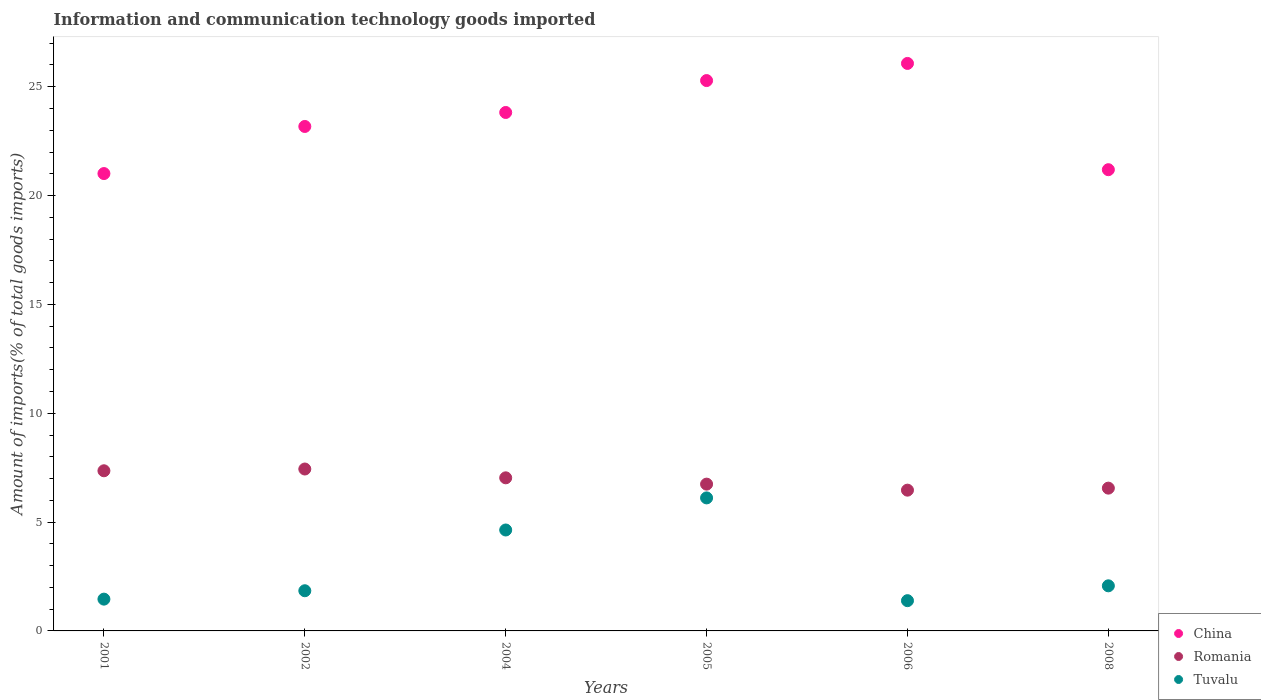Is the number of dotlines equal to the number of legend labels?
Give a very brief answer. Yes. What is the amount of goods imported in Romania in 2004?
Make the answer very short. 7.03. Across all years, what is the maximum amount of goods imported in Romania?
Give a very brief answer. 7.44. Across all years, what is the minimum amount of goods imported in China?
Your answer should be very brief. 21.01. What is the total amount of goods imported in Romania in the graph?
Make the answer very short. 41.6. What is the difference between the amount of goods imported in China in 2004 and that in 2006?
Keep it short and to the point. -2.25. What is the difference between the amount of goods imported in Romania in 2002 and the amount of goods imported in Tuvalu in 2001?
Give a very brief answer. 5.98. What is the average amount of goods imported in Tuvalu per year?
Your answer should be compact. 2.92. In the year 2008, what is the difference between the amount of goods imported in Tuvalu and amount of goods imported in China?
Make the answer very short. -19.12. In how many years, is the amount of goods imported in Tuvalu greater than 1 %?
Ensure brevity in your answer.  6. What is the ratio of the amount of goods imported in China in 2002 to that in 2004?
Offer a terse response. 0.97. Is the amount of goods imported in China in 2002 less than that in 2008?
Your answer should be compact. No. What is the difference between the highest and the second highest amount of goods imported in Romania?
Offer a terse response. 0.08. What is the difference between the highest and the lowest amount of goods imported in Tuvalu?
Provide a short and direct response. 4.72. Is it the case that in every year, the sum of the amount of goods imported in China and amount of goods imported in Tuvalu  is greater than the amount of goods imported in Romania?
Give a very brief answer. Yes. Is the amount of goods imported in Tuvalu strictly greater than the amount of goods imported in China over the years?
Give a very brief answer. No. How many dotlines are there?
Your response must be concise. 3. How many years are there in the graph?
Keep it short and to the point. 6. What is the difference between two consecutive major ticks on the Y-axis?
Ensure brevity in your answer.  5. Does the graph contain any zero values?
Your response must be concise. No. Where does the legend appear in the graph?
Offer a very short reply. Bottom right. What is the title of the graph?
Make the answer very short. Information and communication technology goods imported. Does "Russian Federation" appear as one of the legend labels in the graph?
Provide a succinct answer. No. What is the label or title of the X-axis?
Ensure brevity in your answer.  Years. What is the label or title of the Y-axis?
Ensure brevity in your answer.  Amount of imports(% of total goods imports). What is the Amount of imports(% of total goods imports) of China in 2001?
Your response must be concise. 21.01. What is the Amount of imports(% of total goods imports) of Romania in 2001?
Provide a succinct answer. 7.36. What is the Amount of imports(% of total goods imports) of Tuvalu in 2001?
Provide a short and direct response. 1.46. What is the Amount of imports(% of total goods imports) of China in 2002?
Your answer should be very brief. 23.17. What is the Amount of imports(% of total goods imports) in Romania in 2002?
Give a very brief answer. 7.44. What is the Amount of imports(% of total goods imports) of Tuvalu in 2002?
Make the answer very short. 1.85. What is the Amount of imports(% of total goods imports) in China in 2004?
Provide a succinct answer. 23.82. What is the Amount of imports(% of total goods imports) in Romania in 2004?
Your answer should be compact. 7.03. What is the Amount of imports(% of total goods imports) in Tuvalu in 2004?
Provide a succinct answer. 4.64. What is the Amount of imports(% of total goods imports) in China in 2005?
Keep it short and to the point. 25.28. What is the Amount of imports(% of total goods imports) in Romania in 2005?
Make the answer very short. 6.74. What is the Amount of imports(% of total goods imports) in Tuvalu in 2005?
Provide a succinct answer. 6.11. What is the Amount of imports(% of total goods imports) in China in 2006?
Offer a terse response. 26.07. What is the Amount of imports(% of total goods imports) in Romania in 2006?
Your answer should be very brief. 6.47. What is the Amount of imports(% of total goods imports) in Tuvalu in 2006?
Make the answer very short. 1.39. What is the Amount of imports(% of total goods imports) of China in 2008?
Give a very brief answer. 21.19. What is the Amount of imports(% of total goods imports) of Romania in 2008?
Give a very brief answer. 6.56. What is the Amount of imports(% of total goods imports) of Tuvalu in 2008?
Provide a succinct answer. 2.07. Across all years, what is the maximum Amount of imports(% of total goods imports) in China?
Your answer should be compact. 26.07. Across all years, what is the maximum Amount of imports(% of total goods imports) in Romania?
Ensure brevity in your answer.  7.44. Across all years, what is the maximum Amount of imports(% of total goods imports) in Tuvalu?
Keep it short and to the point. 6.11. Across all years, what is the minimum Amount of imports(% of total goods imports) in China?
Make the answer very short. 21.01. Across all years, what is the minimum Amount of imports(% of total goods imports) in Romania?
Your answer should be compact. 6.47. Across all years, what is the minimum Amount of imports(% of total goods imports) in Tuvalu?
Give a very brief answer. 1.39. What is the total Amount of imports(% of total goods imports) of China in the graph?
Your answer should be very brief. 140.54. What is the total Amount of imports(% of total goods imports) in Romania in the graph?
Your answer should be very brief. 41.6. What is the total Amount of imports(% of total goods imports) of Tuvalu in the graph?
Keep it short and to the point. 17.51. What is the difference between the Amount of imports(% of total goods imports) in China in 2001 and that in 2002?
Offer a very short reply. -2.16. What is the difference between the Amount of imports(% of total goods imports) in Romania in 2001 and that in 2002?
Ensure brevity in your answer.  -0.08. What is the difference between the Amount of imports(% of total goods imports) in Tuvalu in 2001 and that in 2002?
Make the answer very short. -0.39. What is the difference between the Amount of imports(% of total goods imports) of China in 2001 and that in 2004?
Offer a very short reply. -2.81. What is the difference between the Amount of imports(% of total goods imports) of Romania in 2001 and that in 2004?
Offer a terse response. 0.32. What is the difference between the Amount of imports(% of total goods imports) in Tuvalu in 2001 and that in 2004?
Ensure brevity in your answer.  -3.18. What is the difference between the Amount of imports(% of total goods imports) of China in 2001 and that in 2005?
Offer a terse response. -4.27. What is the difference between the Amount of imports(% of total goods imports) in Romania in 2001 and that in 2005?
Keep it short and to the point. 0.61. What is the difference between the Amount of imports(% of total goods imports) of Tuvalu in 2001 and that in 2005?
Give a very brief answer. -4.65. What is the difference between the Amount of imports(% of total goods imports) of China in 2001 and that in 2006?
Your response must be concise. -5.06. What is the difference between the Amount of imports(% of total goods imports) of Romania in 2001 and that in 2006?
Provide a succinct answer. 0.89. What is the difference between the Amount of imports(% of total goods imports) in Tuvalu in 2001 and that in 2006?
Your answer should be very brief. 0.07. What is the difference between the Amount of imports(% of total goods imports) in China in 2001 and that in 2008?
Offer a terse response. -0.18. What is the difference between the Amount of imports(% of total goods imports) of Romania in 2001 and that in 2008?
Provide a short and direct response. 0.8. What is the difference between the Amount of imports(% of total goods imports) of Tuvalu in 2001 and that in 2008?
Provide a succinct answer. -0.61. What is the difference between the Amount of imports(% of total goods imports) of China in 2002 and that in 2004?
Your response must be concise. -0.64. What is the difference between the Amount of imports(% of total goods imports) of Romania in 2002 and that in 2004?
Ensure brevity in your answer.  0.4. What is the difference between the Amount of imports(% of total goods imports) of Tuvalu in 2002 and that in 2004?
Provide a short and direct response. -2.79. What is the difference between the Amount of imports(% of total goods imports) in China in 2002 and that in 2005?
Give a very brief answer. -2.11. What is the difference between the Amount of imports(% of total goods imports) of Romania in 2002 and that in 2005?
Offer a very short reply. 0.69. What is the difference between the Amount of imports(% of total goods imports) of Tuvalu in 2002 and that in 2005?
Your answer should be compact. -4.26. What is the difference between the Amount of imports(% of total goods imports) of China in 2002 and that in 2006?
Ensure brevity in your answer.  -2.9. What is the difference between the Amount of imports(% of total goods imports) in Romania in 2002 and that in 2006?
Offer a terse response. 0.97. What is the difference between the Amount of imports(% of total goods imports) in Tuvalu in 2002 and that in 2006?
Ensure brevity in your answer.  0.46. What is the difference between the Amount of imports(% of total goods imports) in China in 2002 and that in 2008?
Offer a very short reply. 1.99. What is the difference between the Amount of imports(% of total goods imports) in Romania in 2002 and that in 2008?
Your response must be concise. 0.88. What is the difference between the Amount of imports(% of total goods imports) of Tuvalu in 2002 and that in 2008?
Ensure brevity in your answer.  -0.23. What is the difference between the Amount of imports(% of total goods imports) in China in 2004 and that in 2005?
Your answer should be compact. -1.47. What is the difference between the Amount of imports(% of total goods imports) of Romania in 2004 and that in 2005?
Provide a succinct answer. 0.29. What is the difference between the Amount of imports(% of total goods imports) of Tuvalu in 2004 and that in 2005?
Your response must be concise. -1.47. What is the difference between the Amount of imports(% of total goods imports) in China in 2004 and that in 2006?
Your answer should be very brief. -2.25. What is the difference between the Amount of imports(% of total goods imports) in Romania in 2004 and that in 2006?
Provide a succinct answer. 0.57. What is the difference between the Amount of imports(% of total goods imports) of Tuvalu in 2004 and that in 2006?
Give a very brief answer. 3.25. What is the difference between the Amount of imports(% of total goods imports) of China in 2004 and that in 2008?
Your response must be concise. 2.63. What is the difference between the Amount of imports(% of total goods imports) of Romania in 2004 and that in 2008?
Your response must be concise. 0.47. What is the difference between the Amount of imports(% of total goods imports) in Tuvalu in 2004 and that in 2008?
Provide a succinct answer. 2.56. What is the difference between the Amount of imports(% of total goods imports) in China in 2005 and that in 2006?
Ensure brevity in your answer.  -0.79. What is the difference between the Amount of imports(% of total goods imports) in Romania in 2005 and that in 2006?
Provide a short and direct response. 0.28. What is the difference between the Amount of imports(% of total goods imports) of Tuvalu in 2005 and that in 2006?
Provide a short and direct response. 4.72. What is the difference between the Amount of imports(% of total goods imports) of China in 2005 and that in 2008?
Offer a terse response. 4.09. What is the difference between the Amount of imports(% of total goods imports) in Romania in 2005 and that in 2008?
Make the answer very short. 0.18. What is the difference between the Amount of imports(% of total goods imports) in Tuvalu in 2005 and that in 2008?
Keep it short and to the point. 4.04. What is the difference between the Amount of imports(% of total goods imports) in China in 2006 and that in 2008?
Offer a very short reply. 4.88. What is the difference between the Amount of imports(% of total goods imports) of Romania in 2006 and that in 2008?
Your response must be concise. -0.09. What is the difference between the Amount of imports(% of total goods imports) of Tuvalu in 2006 and that in 2008?
Ensure brevity in your answer.  -0.68. What is the difference between the Amount of imports(% of total goods imports) of China in 2001 and the Amount of imports(% of total goods imports) of Romania in 2002?
Your answer should be compact. 13.57. What is the difference between the Amount of imports(% of total goods imports) in China in 2001 and the Amount of imports(% of total goods imports) in Tuvalu in 2002?
Ensure brevity in your answer.  19.16. What is the difference between the Amount of imports(% of total goods imports) of Romania in 2001 and the Amount of imports(% of total goods imports) of Tuvalu in 2002?
Provide a succinct answer. 5.51. What is the difference between the Amount of imports(% of total goods imports) of China in 2001 and the Amount of imports(% of total goods imports) of Romania in 2004?
Your answer should be very brief. 13.98. What is the difference between the Amount of imports(% of total goods imports) of China in 2001 and the Amount of imports(% of total goods imports) of Tuvalu in 2004?
Your answer should be very brief. 16.37. What is the difference between the Amount of imports(% of total goods imports) of Romania in 2001 and the Amount of imports(% of total goods imports) of Tuvalu in 2004?
Provide a short and direct response. 2.72. What is the difference between the Amount of imports(% of total goods imports) in China in 2001 and the Amount of imports(% of total goods imports) in Romania in 2005?
Provide a succinct answer. 14.27. What is the difference between the Amount of imports(% of total goods imports) in China in 2001 and the Amount of imports(% of total goods imports) in Tuvalu in 2005?
Keep it short and to the point. 14.9. What is the difference between the Amount of imports(% of total goods imports) in Romania in 2001 and the Amount of imports(% of total goods imports) in Tuvalu in 2005?
Make the answer very short. 1.25. What is the difference between the Amount of imports(% of total goods imports) of China in 2001 and the Amount of imports(% of total goods imports) of Romania in 2006?
Your answer should be very brief. 14.54. What is the difference between the Amount of imports(% of total goods imports) of China in 2001 and the Amount of imports(% of total goods imports) of Tuvalu in 2006?
Keep it short and to the point. 19.62. What is the difference between the Amount of imports(% of total goods imports) of Romania in 2001 and the Amount of imports(% of total goods imports) of Tuvalu in 2006?
Ensure brevity in your answer.  5.97. What is the difference between the Amount of imports(% of total goods imports) of China in 2001 and the Amount of imports(% of total goods imports) of Romania in 2008?
Ensure brevity in your answer.  14.45. What is the difference between the Amount of imports(% of total goods imports) in China in 2001 and the Amount of imports(% of total goods imports) in Tuvalu in 2008?
Give a very brief answer. 18.94. What is the difference between the Amount of imports(% of total goods imports) in Romania in 2001 and the Amount of imports(% of total goods imports) in Tuvalu in 2008?
Offer a very short reply. 5.28. What is the difference between the Amount of imports(% of total goods imports) of China in 2002 and the Amount of imports(% of total goods imports) of Romania in 2004?
Keep it short and to the point. 16.14. What is the difference between the Amount of imports(% of total goods imports) of China in 2002 and the Amount of imports(% of total goods imports) of Tuvalu in 2004?
Keep it short and to the point. 18.54. What is the difference between the Amount of imports(% of total goods imports) in Romania in 2002 and the Amount of imports(% of total goods imports) in Tuvalu in 2004?
Ensure brevity in your answer.  2.8. What is the difference between the Amount of imports(% of total goods imports) of China in 2002 and the Amount of imports(% of total goods imports) of Romania in 2005?
Ensure brevity in your answer.  16.43. What is the difference between the Amount of imports(% of total goods imports) in China in 2002 and the Amount of imports(% of total goods imports) in Tuvalu in 2005?
Keep it short and to the point. 17.06. What is the difference between the Amount of imports(% of total goods imports) of Romania in 2002 and the Amount of imports(% of total goods imports) of Tuvalu in 2005?
Ensure brevity in your answer.  1.33. What is the difference between the Amount of imports(% of total goods imports) of China in 2002 and the Amount of imports(% of total goods imports) of Romania in 2006?
Give a very brief answer. 16.71. What is the difference between the Amount of imports(% of total goods imports) in China in 2002 and the Amount of imports(% of total goods imports) in Tuvalu in 2006?
Your response must be concise. 21.78. What is the difference between the Amount of imports(% of total goods imports) in Romania in 2002 and the Amount of imports(% of total goods imports) in Tuvalu in 2006?
Your response must be concise. 6.05. What is the difference between the Amount of imports(% of total goods imports) in China in 2002 and the Amount of imports(% of total goods imports) in Romania in 2008?
Give a very brief answer. 16.61. What is the difference between the Amount of imports(% of total goods imports) in China in 2002 and the Amount of imports(% of total goods imports) in Tuvalu in 2008?
Make the answer very short. 21.1. What is the difference between the Amount of imports(% of total goods imports) in Romania in 2002 and the Amount of imports(% of total goods imports) in Tuvalu in 2008?
Your answer should be very brief. 5.37. What is the difference between the Amount of imports(% of total goods imports) of China in 2004 and the Amount of imports(% of total goods imports) of Romania in 2005?
Provide a short and direct response. 17.07. What is the difference between the Amount of imports(% of total goods imports) in China in 2004 and the Amount of imports(% of total goods imports) in Tuvalu in 2005?
Make the answer very short. 17.71. What is the difference between the Amount of imports(% of total goods imports) in Romania in 2004 and the Amount of imports(% of total goods imports) in Tuvalu in 2005?
Give a very brief answer. 0.92. What is the difference between the Amount of imports(% of total goods imports) in China in 2004 and the Amount of imports(% of total goods imports) in Romania in 2006?
Provide a succinct answer. 17.35. What is the difference between the Amount of imports(% of total goods imports) of China in 2004 and the Amount of imports(% of total goods imports) of Tuvalu in 2006?
Offer a terse response. 22.43. What is the difference between the Amount of imports(% of total goods imports) of Romania in 2004 and the Amount of imports(% of total goods imports) of Tuvalu in 2006?
Your response must be concise. 5.64. What is the difference between the Amount of imports(% of total goods imports) in China in 2004 and the Amount of imports(% of total goods imports) in Romania in 2008?
Your answer should be compact. 17.26. What is the difference between the Amount of imports(% of total goods imports) of China in 2004 and the Amount of imports(% of total goods imports) of Tuvalu in 2008?
Provide a succinct answer. 21.74. What is the difference between the Amount of imports(% of total goods imports) of Romania in 2004 and the Amount of imports(% of total goods imports) of Tuvalu in 2008?
Keep it short and to the point. 4.96. What is the difference between the Amount of imports(% of total goods imports) in China in 2005 and the Amount of imports(% of total goods imports) in Romania in 2006?
Ensure brevity in your answer.  18.82. What is the difference between the Amount of imports(% of total goods imports) in China in 2005 and the Amount of imports(% of total goods imports) in Tuvalu in 2006?
Make the answer very short. 23.89. What is the difference between the Amount of imports(% of total goods imports) of Romania in 2005 and the Amount of imports(% of total goods imports) of Tuvalu in 2006?
Offer a terse response. 5.35. What is the difference between the Amount of imports(% of total goods imports) in China in 2005 and the Amount of imports(% of total goods imports) in Romania in 2008?
Your response must be concise. 18.72. What is the difference between the Amount of imports(% of total goods imports) of China in 2005 and the Amount of imports(% of total goods imports) of Tuvalu in 2008?
Provide a short and direct response. 23.21. What is the difference between the Amount of imports(% of total goods imports) in Romania in 2005 and the Amount of imports(% of total goods imports) in Tuvalu in 2008?
Your response must be concise. 4.67. What is the difference between the Amount of imports(% of total goods imports) of China in 2006 and the Amount of imports(% of total goods imports) of Romania in 2008?
Give a very brief answer. 19.51. What is the difference between the Amount of imports(% of total goods imports) of China in 2006 and the Amount of imports(% of total goods imports) of Tuvalu in 2008?
Keep it short and to the point. 24. What is the difference between the Amount of imports(% of total goods imports) in Romania in 2006 and the Amount of imports(% of total goods imports) in Tuvalu in 2008?
Provide a short and direct response. 4.39. What is the average Amount of imports(% of total goods imports) of China per year?
Ensure brevity in your answer.  23.42. What is the average Amount of imports(% of total goods imports) of Romania per year?
Your answer should be very brief. 6.93. What is the average Amount of imports(% of total goods imports) in Tuvalu per year?
Offer a very short reply. 2.92. In the year 2001, what is the difference between the Amount of imports(% of total goods imports) of China and Amount of imports(% of total goods imports) of Romania?
Give a very brief answer. 13.65. In the year 2001, what is the difference between the Amount of imports(% of total goods imports) of China and Amount of imports(% of total goods imports) of Tuvalu?
Provide a succinct answer. 19.55. In the year 2001, what is the difference between the Amount of imports(% of total goods imports) of Romania and Amount of imports(% of total goods imports) of Tuvalu?
Your response must be concise. 5.9. In the year 2002, what is the difference between the Amount of imports(% of total goods imports) in China and Amount of imports(% of total goods imports) in Romania?
Provide a short and direct response. 15.74. In the year 2002, what is the difference between the Amount of imports(% of total goods imports) of China and Amount of imports(% of total goods imports) of Tuvalu?
Keep it short and to the point. 21.33. In the year 2002, what is the difference between the Amount of imports(% of total goods imports) in Romania and Amount of imports(% of total goods imports) in Tuvalu?
Your answer should be compact. 5.59. In the year 2004, what is the difference between the Amount of imports(% of total goods imports) of China and Amount of imports(% of total goods imports) of Romania?
Keep it short and to the point. 16.78. In the year 2004, what is the difference between the Amount of imports(% of total goods imports) of China and Amount of imports(% of total goods imports) of Tuvalu?
Offer a terse response. 19.18. In the year 2004, what is the difference between the Amount of imports(% of total goods imports) in Romania and Amount of imports(% of total goods imports) in Tuvalu?
Make the answer very short. 2.4. In the year 2005, what is the difference between the Amount of imports(% of total goods imports) of China and Amount of imports(% of total goods imports) of Romania?
Give a very brief answer. 18.54. In the year 2005, what is the difference between the Amount of imports(% of total goods imports) of China and Amount of imports(% of total goods imports) of Tuvalu?
Give a very brief answer. 19.17. In the year 2005, what is the difference between the Amount of imports(% of total goods imports) in Romania and Amount of imports(% of total goods imports) in Tuvalu?
Offer a very short reply. 0.63. In the year 2006, what is the difference between the Amount of imports(% of total goods imports) in China and Amount of imports(% of total goods imports) in Romania?
Make the answer very short. 19.6. In the year 2006, what is the difference between the Amount of imports(% of total goods imports) in China and Amount of imports(% of total goods imports) in Tuvalu?
Your answer should be very brief. 24.68. In the year 2006, what is the difference between the Amount of imports(% of total goods imports) of Romania and Amount of imports(% of total goods imports) of Tuvalu?
Your answer should be compact. 5.08. In the year 2008, what is the difference between the Amount of imports(% of total goods imports) of China and Amount of imports(% of total goods imports) of Romania?
Your answer should be compact. 14.63. In the year 2008, what is the difference between the Amount of imports(% of total goods imports) of China and Amount of imports(% of total goods imports) of Tuvalu?
Your answer should be very brief. 19.12. In the year 2008, what is the difference between the Amount of imports(% of total goods imports) of Romania and Amount of imports(% of total goods imports) of Tuvalu?
Keep it short and to the point. 4.49. What is the ratio of the Amount of imports(% of total goods imports) of China in 2001 to that in 2002?
Your response must be concise. 0.91. What is the ratio of the Amount of imports(% of total goods imports) of Tuvalu in 2001 to that in 2002?
Your answer should be compact. 0.79. What is the ratio of the Amount of imports(% of total goods imports) in China in 2001 to that in 2004?
Your answer should be very brief. 0.88. What is the ratio of the Amount of imports(% of total goods imports) of Romania in 2001 to that in 2004?
Ensure brevity in your answer.  1.05. What is the ratio of the Amount of imports(% of total goods imports) of Tuvalu in 2001 to that in 2004?
Your answer should be compact. 0.31. What is the ratio of the Amount of imports(% of total goods imports) in China in 2001 to that in 2005?
Make the answer very short. 0.83. What is the ratio of the Amount of imports(% of total goods imports) of Romania in 2001 to that in 2005?
Your answer should be compact. 1.09. What is the ratio of the Amount of imports(% of total goods imports) in Tuvalu in 2001 to that in 2005?
Give a very brief answer. 0.24. What is the ratio of the Amount of imports(% of total goods imports) of China in 2001 to that in 2006?
Give a very brief answer. 0.81. What is the ratio of the Amount of imports(% of total goods imports) in Romania in 2001 to that in 2006?
Provide a short and direct response. 1.14. What is the ratio of the Amount of imports(% of total goods imports) of Tuvalu in 2001 to that in 2006?
Your answer should be very brief. 1.05. What is the ratio of the Amount of imports(% of total goods imports) in China in 2001 to that in 2008?
Offer a terse response. 0.99. What is the ratio of the Amount of imports(% of total goods imports) of Romania in 2001 to that in 2008?
Offer a terse response. 1.12. What is the ratio of the Amount of imports(% of total goods imports) in Tuvalu in 2001 to that in 2008?
Provide a short and direct response. 0.7. What is the ratio of the Amount of imports(% of total goods imports) in Romania in 2002 to that in 2004?
Ensure brevity in your answer.  1.06. What is the ratio of the Amount of imports(% of total goods imports) of Tuvalu in 2002 to that in 2004?
Offer a terse response. 0.4. What is the ratio of the Amount of imports(% of total goods imports) in China in 2002 to that in 2005?
Provide a succinct answer. 0.92. What is the ratio of the Amount of imports(% of total goods imports) in Romania in 2002 to that in 2005?
Ensure brevity in your answer.  1.1. What is the ratio of the Amount of imports(% of total goods imports) in Tuvalu in 2002 to that in 2005?
Your answer should be very brief. 0.3. What is the ratio of the Amount of imports(% of total goods imports) of Romania in 2002 to that in 2006?
Keep it short and to the point. 1.15. What is the ratio of the Amount of imports(% of total goods imports) in Tuvalu in 2002 to that in 2006?
Your response must be concise. 1.33. What is the ratio of the Amount of imports(% of total goods imports) of China in 2002 to that in 2008?
Give a very brief answer. 1.09. What is the ratio of the Amount of imports(% of total goods imports) in Romania in 2002 to that in 2008?
Ensure brevity in your answer.  1.13. What is the ratio of the Amount of imports(% of total goods imports) in Tuvalu in 2002 to that in 2008?
Provide a short and direct response. 0.89. What is the ratio of the Amount of imports(% of total goods imports) of China in 2004 to that in 2005?
Provide a succinct answer. 0.94. What is the ratio of the Amount of imports(% of total goods imports) in Romania in 2004 to that in 2005?
Give a very brief answer. 1.04. What is the ratio of the Amount of imports(% of total goods imports) of Tuvalu in 2004 to that in 2005?
Keep it short and to the point. 0.76. What is the ratio of the Amount of imports(% of total goods imports) of China in 2004 to that in 2006?
Your response must be concise. 0.91. What is the ratio of the Amount of imports(% of total goods imports) of Romania in 2004 to that in 2006?
Give a very brief answer. 1.09. What is the ratio of the Amount of imports(% of total goods imports) of Tuvalu in 2004 to that in 2006?
Your response must be concise. 3.34. What is the ratio of the Amount of imports(% of total goods imports) in China in 2004 to that in 2008?
Offer a terse response. 1.12. What is the ratio of the Amount of imports(% of total goods imports) of Romania in 2004 to that in 2008?
Provide a short and direct response. 1.07. What is the ratio of the Amount of imports(% of total goods imports) in Tuvalu in 2004 to that in 2008?
Provide a short and direct response. 2.24. What is the ratio of the Amount of imports(% of total goods imports) of China in 2005 to that in 2006?
Offer a terse response. 0.97. What is the ratio of the Amount of imports(% of total goods imports) in Romania in 2005 to that in 2006?
Make the answer very short. 1.04. What is the ratio of the Amount of imports(% of total goods imports) of Tuvalu in 2005 to that in 2006?
Provide a succinct answer. 4.4. What is the ratio of the Amount of imports(% of total goods imports) of China in 2005 to that in 2008?
Make the answer very short. 1.19. What is the ratio of the Amount of imports(% of total goods imports) in Romania in 2005 to that in 2008?
Your response must be concise. 1.03. What is the ratio of the Amount of imports(% of total goods imports) in Tuvalu in 2005 to that in 2008?
Provide a succinct answer. 2.95. What is the ratio of the Amount of imports(% of total goods imports) in China in 2006 to that in 2008?
Offer a terse response. 1.23. What is the ratio of the Amount of imports(% of total goods imports) of Romania in 2006 to that in 2008?
Provide a short and direct response. 0.99. What is the ratio of the Amount of imports(% of total goods imports) in Tuvalu in 2006 to that in 2008?
Your answer should be very brief. 0.67. What is the difference between the highest and the second highest Amount of imports(% of total goods imports) of China?
Your answer should be compact. 0.79. What is the difference between the highest and the second highest Amount of imports(% of total goods imports) in Romania?
Ensure brevity in your answer.  0.08. What is the difference between the highest and the second highest Amount of imports(% of total goods imports) of Tuvalu?
Offer a terse response. 1.47. What is the difference between the highest and the lowest Amount of imports(% of total goods imports) in China?
Offer a very short reply. 5.06. What is the difference between the highest and the lowest Amount of imports(% of total goods imports) in Romania?
Your answer should be very brief. 0.97. What is the difference between the highest and the lowest Amount of imports(% of total goods imports) of Tuvalu?
Provide a short and direct response. 4.72. 